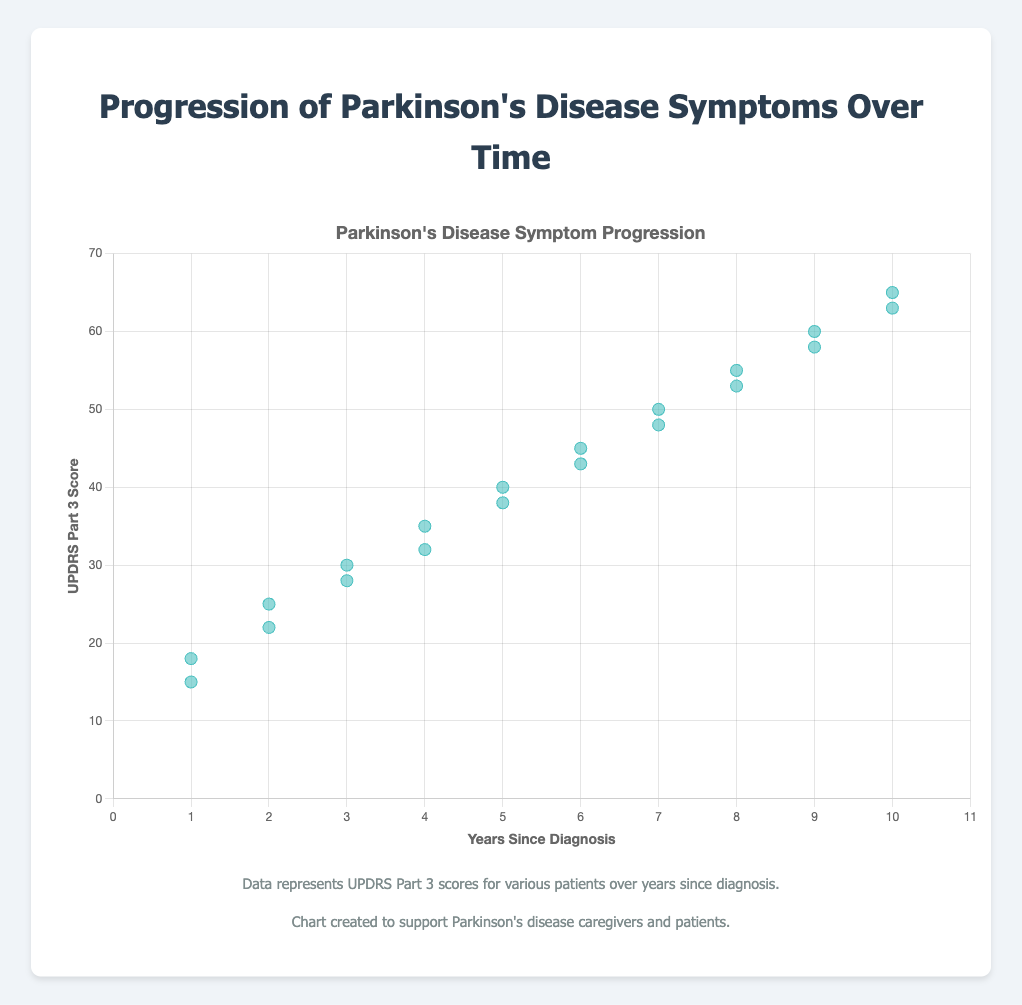What is the title of the chart? The title of the chart is displayed at the top of the figure, indicating the main subject of the chart.
Answer: Progression of Parkinson's Disease Symptoms Over Time What are the labels on the X and Y axes? The X-axis is labeled 'Years Since Diagnosis' and the Y-axis is labeled 'UPDRS Part 3 Score,' which is indicated by the text alongside the respective axes.
Answer: Years Since Diagnosis, UPDRS Part 3 Score What does the trend line represent? The trend line represents the general trend or pattern in the data points, indicating the increase in UPDRS Part 3 scores as the years since diagnosis increase.
Answer: The increase in symptom severity over time How many patient data points are shown on the chart? Each dot on the scatter plot represents a single patient, and you can count the dots to determine the number of data points.
Answer: 20 Which patient has the highest UPDRS Part 3 score and what is that score? By looking at the Y-axis, you can identify the highest data point on the chart. This point corresponds to the patient with the highest score.
Answer: Patient P019, Score 65 What is the average UPDRS Part 3 score for patients 5 years since diagnosis? Locate the data points corresponding to 5 years since diagnosis and average their UPDRS Part 3 scores.
Answer: (40 + 38) / 2 = 39 How does the UPDRS Part 3 score change on average per year since diagnosis? Determine the overall trend in the data by calculating the slope of the trend line or by comparing the scores across different years.
Answer: It increases by approximately 5 points per year Is there a general trend in the progression of symptoms over time? Examine the trend line and the arrangement of the data points to see if there is an overall upward, downward, or no trend.
Answer: Increasing trend What are the minimum and maximum UPDRS Part 3 scores observed in the dataset? Identify the lowest and highest points on the Y-axis corresponding to the data points.
Answer: Minimum: 15, Maximum: 65 